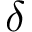Convert formula to latex. <formula><loc_0><loc_0><loc_500><loc_500>\delta</formula> 